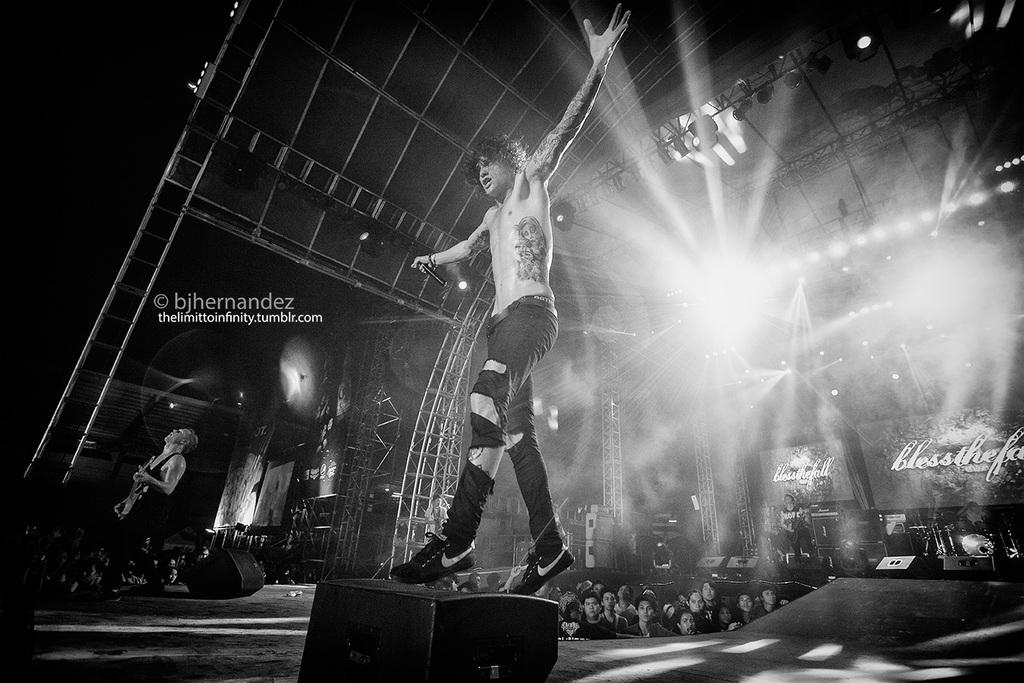What is the main subject of the image? There is a person standing in the center of the image. What is the person in the center holding? The person is holding a mic in his hand. Are there any other people in the image? Yes, there is a person holding a guitar on the right side of the image. What is the color scheme of the image? The image is in black and white. What type of crook can be seen in the image? There is no crook present in the image. How many cents are visible in the image? There are no cents present in the image. 